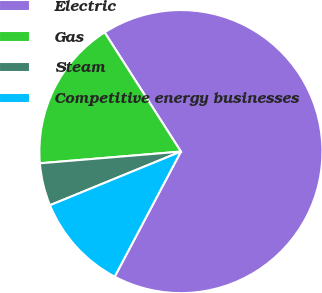Convert chart to OTSL. <chart><loc_0><loc_0><loc_500><loc_500><pie_chart><fcel>Electric<fcel>Gas<fcel>Steam<fcel>Competitive energy businesses<nl><fcel>66.81%<fcel>17.26%<fcel>4.87%<fcel>11.06%<nl></chart> 